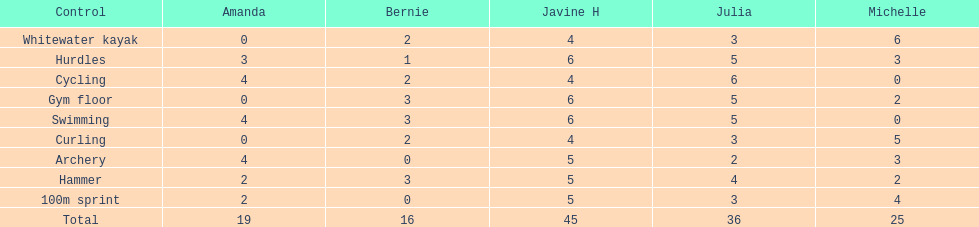Who is the faster runner? Javine H. 